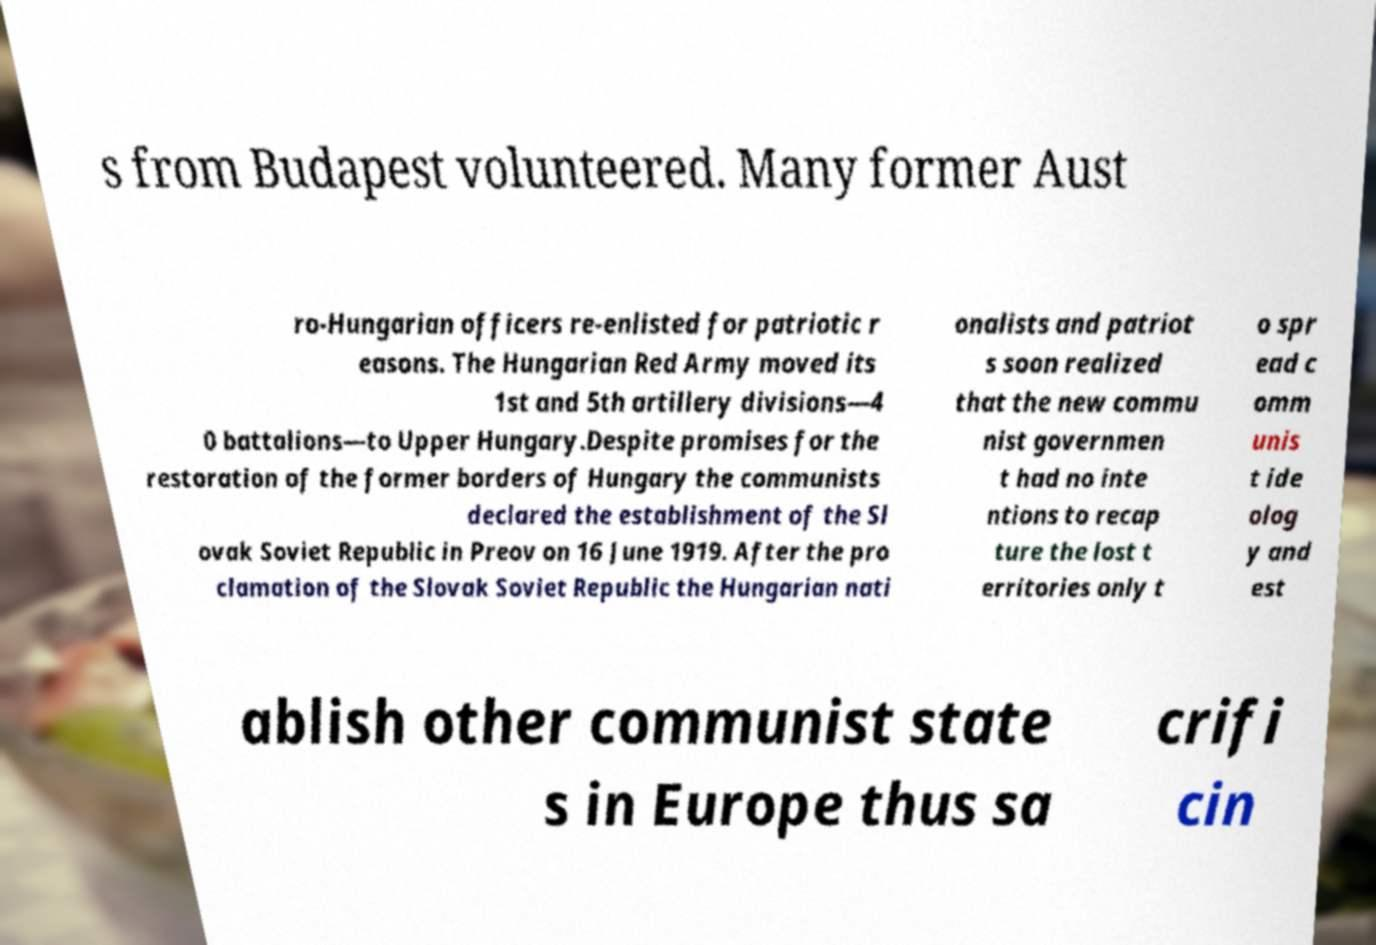Please identify and transcribe the text found in this image. s from Budapest volunteered. Many former Aust ro-Hungarian officers re-enlisted for patriotic r easons. The Hungarian Red Army moved its 1st and 5th artillery divisions—4 0 battalions—to Upper Hungary.Despite promises for the restoration of the former borders of Hungary the communists declared the establishment of the Sl ovak Soviet Republic in Preov on 16 June 1919. After the pro clamation of the Slovak Soviet Republic the Hungarian nati onalists and patriot s soon realized that the new commu nist governmen t had no inte ntions to recap ture the lost t erritories only t o spr ead c omm unis t ide olog y and est ablish other communist state s in Europe thus sa crifi cin 